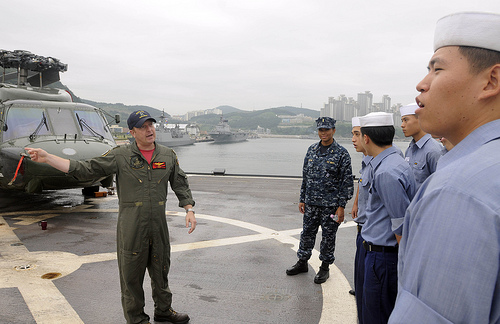<image>
Is there a man to the left of the man? Yes. From this viewpoint, the man is positioned to the left side relative to the man. Where is the helicopter in relation to the man? Is it behind the man? Yes. From this viewpoint, the helicopter is positioned behind the man, with the man partially or fully occluding the helicopter. Is the man next to the man? Yes. The man is positioned adjacent to the man, located nearby in the same general area. 